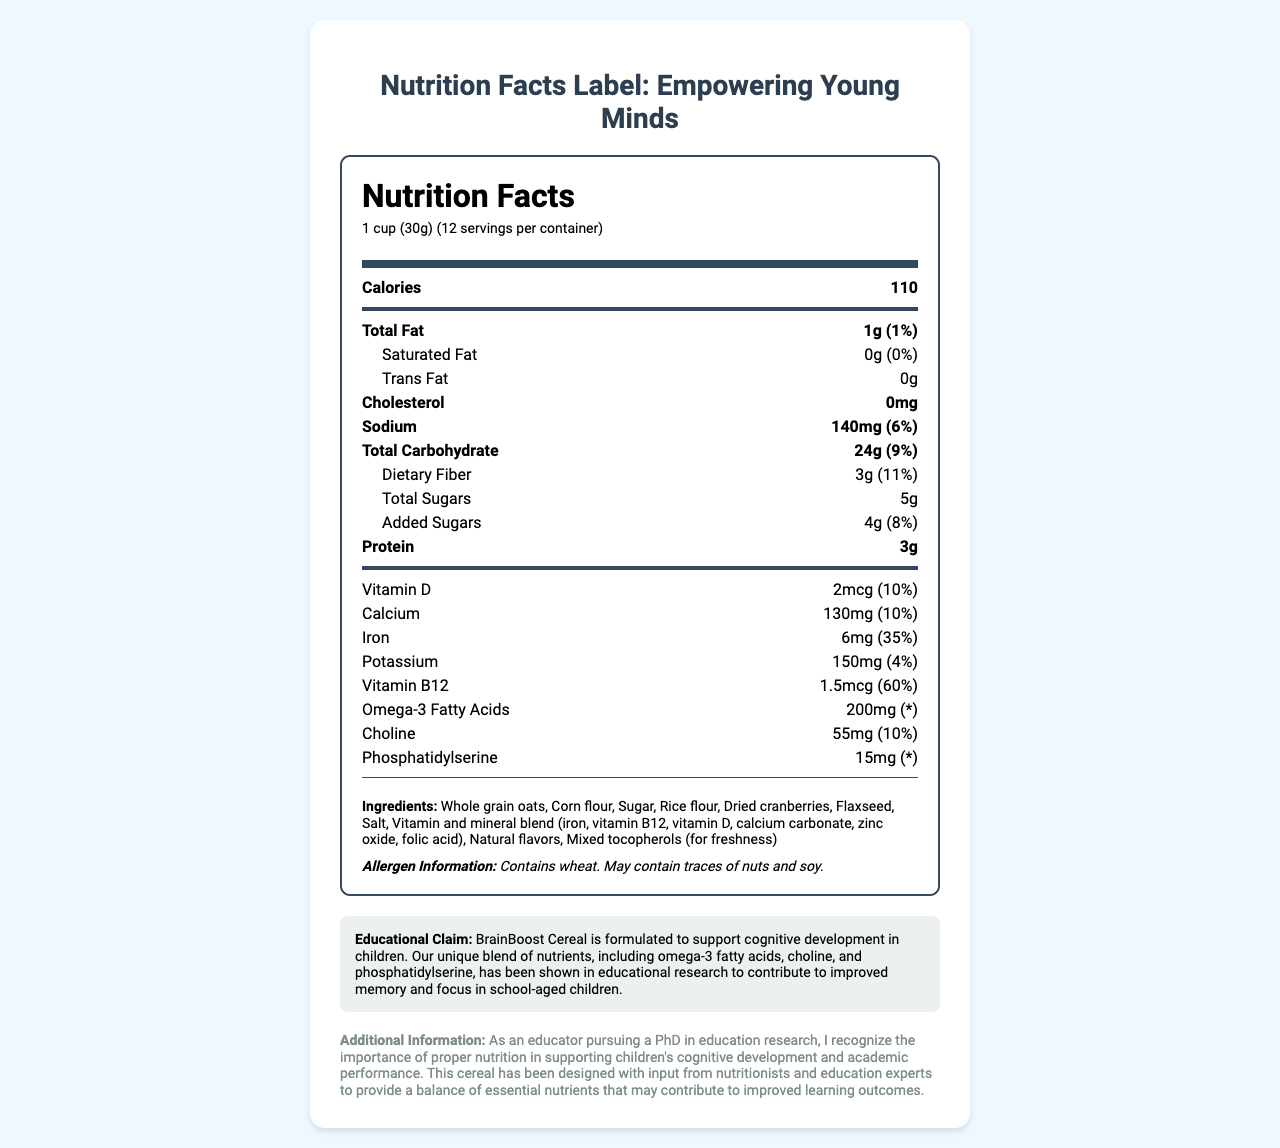what is the product name? The product name is listed at the top of the document.
Answer: BrainBoost Cereal what is the serving size? The serving size is stated at the top of the Nutrition Facts section.
Answer: 1 cup (30g) how many calories are in one serving? The number of calories is listed in a bold font at the top of the Nutrition Facts.
Answer: 110 what is the amount of total fat per serving? The amount of total fat is provided under the bold Total Fat section in the Nutrition Facts.
Answer: 1g how much iron does one serving contain? The amount of iron is clearly listed in the document under the nutrients section.
Answer: 6mg which nutrients are provided at 10% daily value in one serving? A. Vitamin D and Calcium B. Vitamin D and Iron C. Calcium and Potassium D. Iron and Phosphatidylserine Both Vitamin D and Calcium show a daily value of 10% as listed under the nutrient details.
Answer: A. Vitamin D and Calcium how much omega-3 fatty acid is in one serving? A. 100mg B. 150mg C. 200mg D. 250mg The amount of omega-3 fatty acids per serving is 200mg, as indicated in the document.
Answer: C. 200mg does this cereal contain wheat? The allergen information clearly states that the product contains wheat.
Answer: Yes describe the main idea of the document. The document focuses on presenting the nutritional values of BrainBoost Cereal, emphasizing its role in supporting cognitive development in children. It includes detailed nutrition facts and mentions specific ingredients targeted to enhance brain function.
Answer: BrainBoost Cereal is designed to support children's cognitive development through a carefully formulated blend of nutrients. The document provides detailed nutritional information, including serving size, calories, and content of various vitamins and minerals. The cereal includes specific ingredients like omega-3 fatty acids, choline, and phosphatidylserine, which are linked to improved memory and focus. what is the daily value percentage for dietary fiber? The daily value percentage for dietary fiber is listed as 11% next to the amount.
Answer: 11% what ingredients are included to provide freshness? The ingredient list specifies "Mixed tocopherols (for freshness)."
Answer: Mixed tocopherols what is the educational claim of the cereal related to cognitive development? The educational claim is stated towards the bottom, emphasizing the cereal's role in supporting cognitive development.
Answer: BrainBoost Cereal is formulated to support cognitive development in children, with a blend of nutrients shown to contribute to improved memory and focus. how many servings are per container? A. 10 B. 12 C. 14 D. 16 The "servings per container" is listed as 12 at the very top near the serving size.
Answer: B. 12 how much sugar is present in one serving? The total sugars are listed as 5g in the details for carbohydrates.
Answer: 5g what additional information is shared by the document besides nutritional facts? The additional information section highlights the collaborative design process and underscores the link between nutrition and academic performance.
Answer: The document shares that BrainBoost Cereal is designed with input from nutritionists and education experts to support children's cognitive development and mentions the importance of proper nutrition in academic performance. what is the source of natural flavors in the ingredients list? The document does not specify the source of natural flavors, only that they are included.
Answer: Not enough information are there any traces of nuts and soy in the cereal? The allergen information mentions that the product may contain traces of nuts and soy.
Answer: May contain traces of nuts and soy 